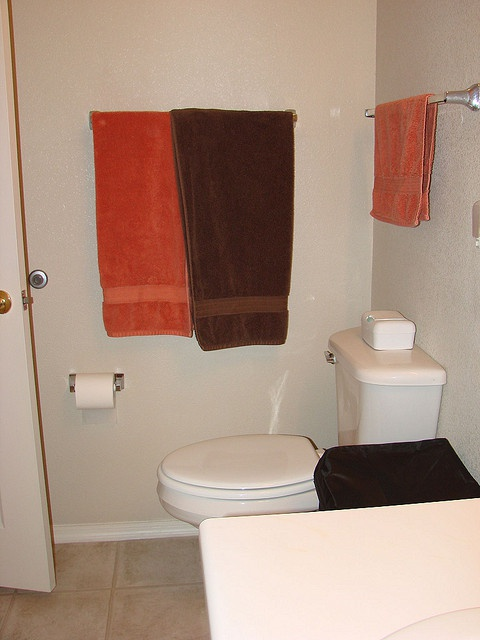Describe the objects in this image and their specific colors. I can see sink in tan, lightgray, black, and gray tones and toilet in tan, darkgray, and lightgray tones in this image. 